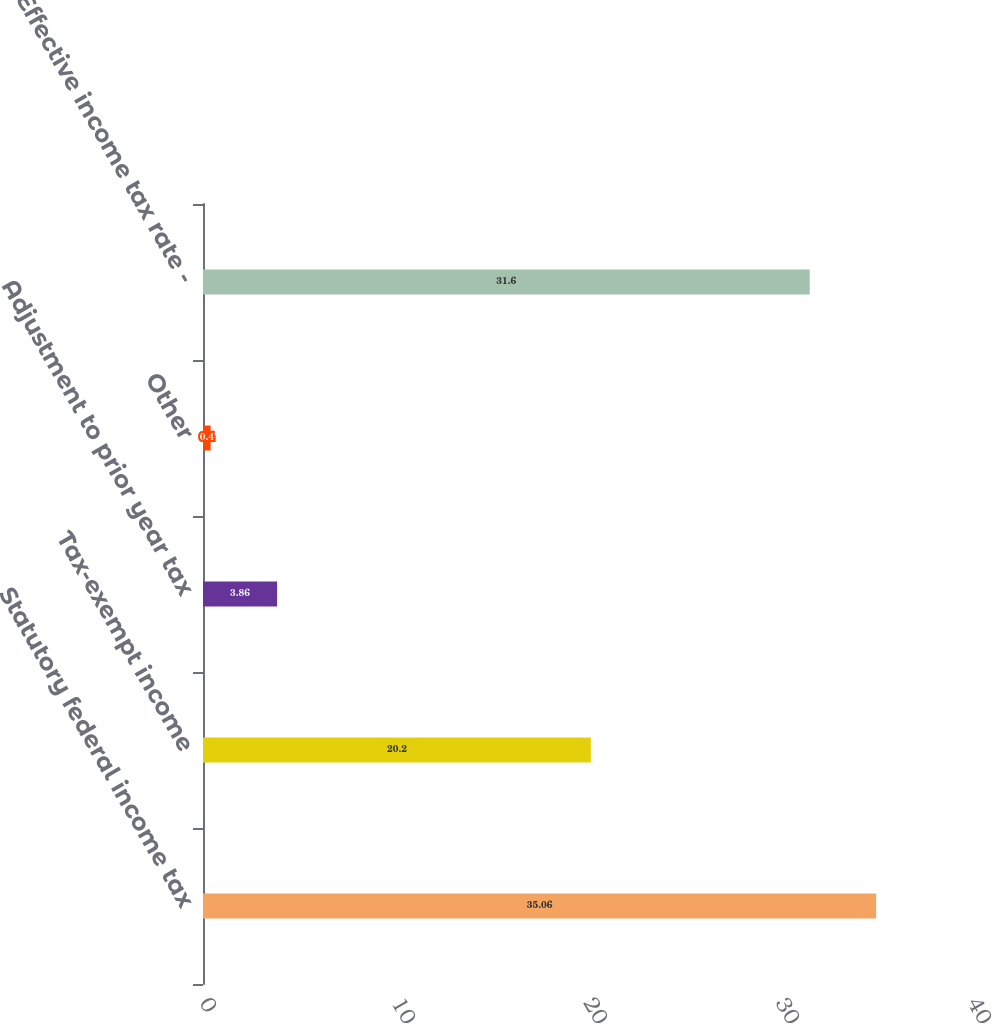Convert chart. <chart><loc_0><loc_0><loc_500><loc_500><bar_chart><fcel>Statutory federal income tax<fcel>Tax-exempt income<fcel>Adjustment to prior year tax<fcel>Other<fcel>Effective income tax rate -<nl><fcel>35.06<fcel>20.2<fcel>3.86<fcel>0.4<fcel>31.6<nl></chart> 